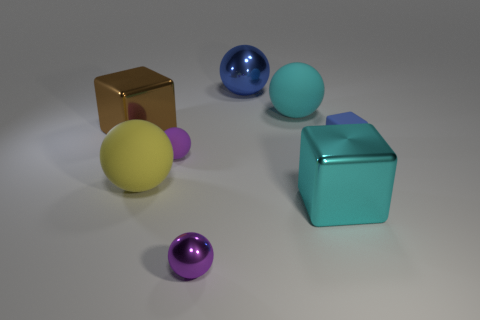There is another purple thing that is the same shape as the purple rubber object; what is its size?
Provide a succinct answer. Small. What material is the other small thing that is the same color as the small metallic thing?
Offer a very short reply. Rubber. There is a tiny thing that is made of the same material as the small blue block; what is its color?
Your answer should be very brief. Purple. What is the color of the other large metallic object that is the same shape as the brown thing?
Your answer should be compact. Cyan. There is a tiny matte block; is it the same color as the large cube to the left of the large yellow thing?
Your response must be concise. No. There is a small ball that is behind the big yellow matte ball; what is it made of?
Provide a short and direct response. Rubber. Is there a tiny matte sphere that has the same color as the tiny metal ball?
Provide a short and direct response. Yes. There is a shiny ball that is the same size as the brown object; what color is it?
Make the answer very short. Blue. How many big things are brown cubes or metal balls?
Give a very brief answer. 2. Is the number of tiny purple shiny objects that are behind the yellow thing the same as the number of large yellow rubber spheres left of the large brown cube?
Your answer should be compact. Yes. 